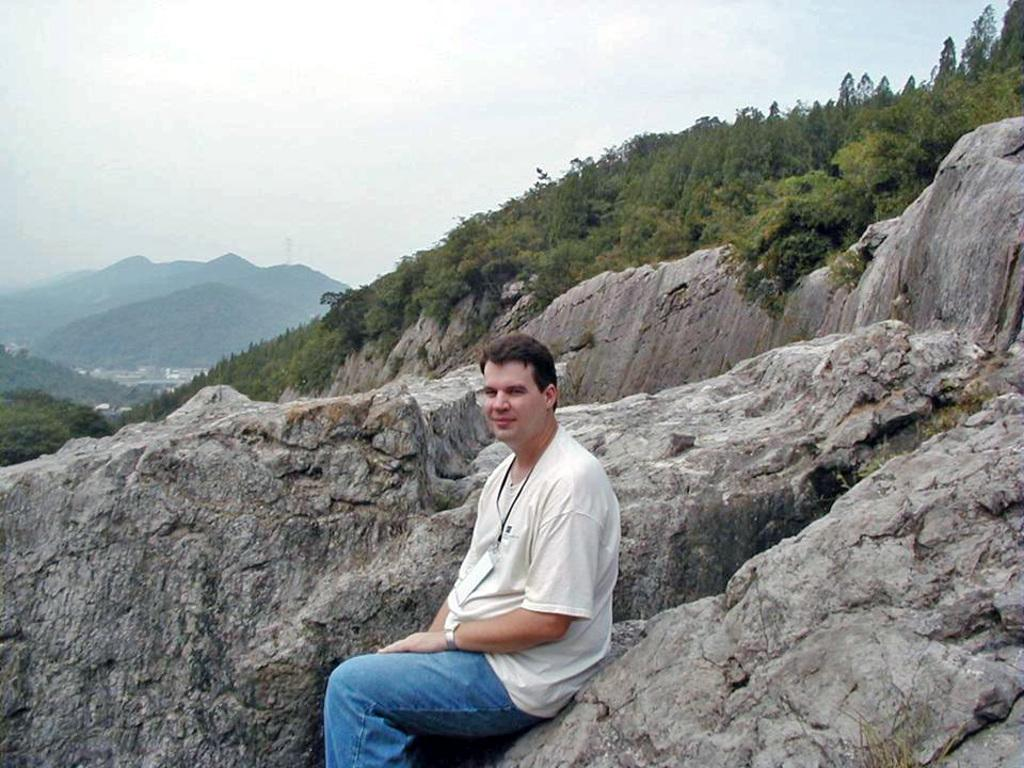What is the person in the image doing? There is a person sitting on a rock in the image. What type of natural environment is visible in the image? There are trees and hills in the image. What is the condition of the sky in the image? The sky is cloudy in the image. What type of locket is the person wearing in the image? There is no locket visible in the image; the person is sitting on a rock with no jewelry mentioned. 